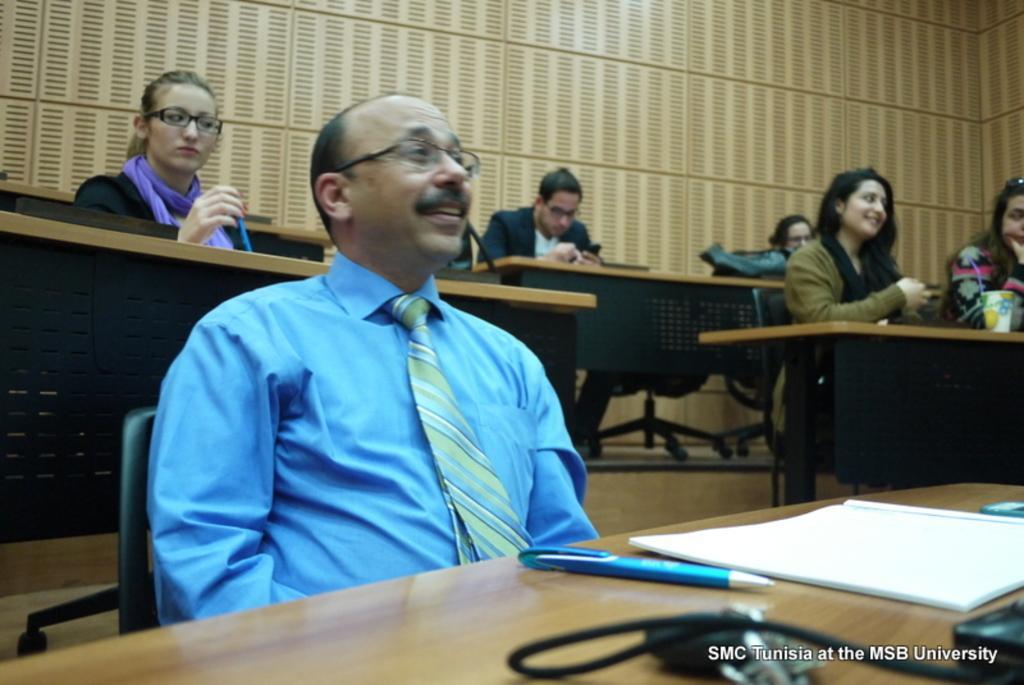Describe this image in one or two sentences. In this picture we can see some people sitting on chairs in front of tables, the table in front of this man consists of a book and pen, in the background we can see a woman holding a pen, we can also see a cup here. 